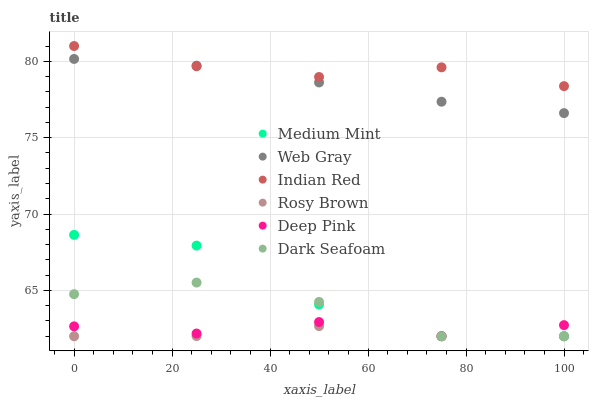Does Rosy Brown have the minimum area under the curve?
Answer yes or no. Yes. Does Indian Red have the maximum area under the curve?
Answer yes or no. Yes. Does Web Gray have the minimum area under the curve?
Answer yes or no. No. Does Web Gray have the maximum area under the curve?
Answer yes or no. No. Is Web Gray the smoothest?
Answer yes or no. Yes. Is Medium Mint the roughest?
Answer yes or no. Yes. Is Rosy Brown the smoothest?
Answer yes or no. No. Is Rosy Brown the roughest?
Answer yes or no. No. Does Medium Mint have the lowest value?
Answer yes or no. Yes. Does Web Gray have the lowest value?
Answer yes or no. No. Does Indian Red have the highest value?
Answer yes or no. Yes. Does Web Gray have the highest value?
Answer yes or no. No. Is Medium Mint less than Web Gray?
Answer yes or no. Yes. Is Indian Red greater than Deep Pink?
Answer yes or no. Yes. Does Medium Mint intersect Deep Pink?
Answer yes or no. Yes. Is Medium Mint less than Deep Pink?
Answer yes or no. No. Is Medium Mint greater than Deep Pink?
Answer yes or no. No. Does Medium Mint intersect Web Gray?
Answer yes or no. No. 